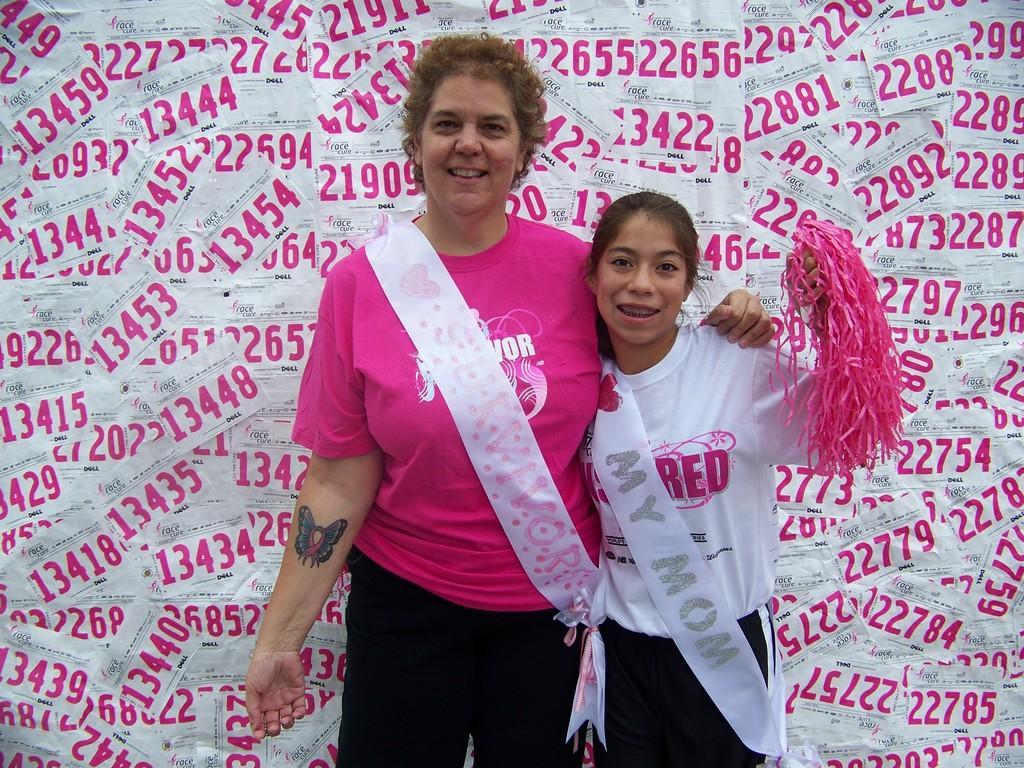Can you describe this image briefly? In this image we can see two persons standing and wearing sashes, in the background we can see some posters. 